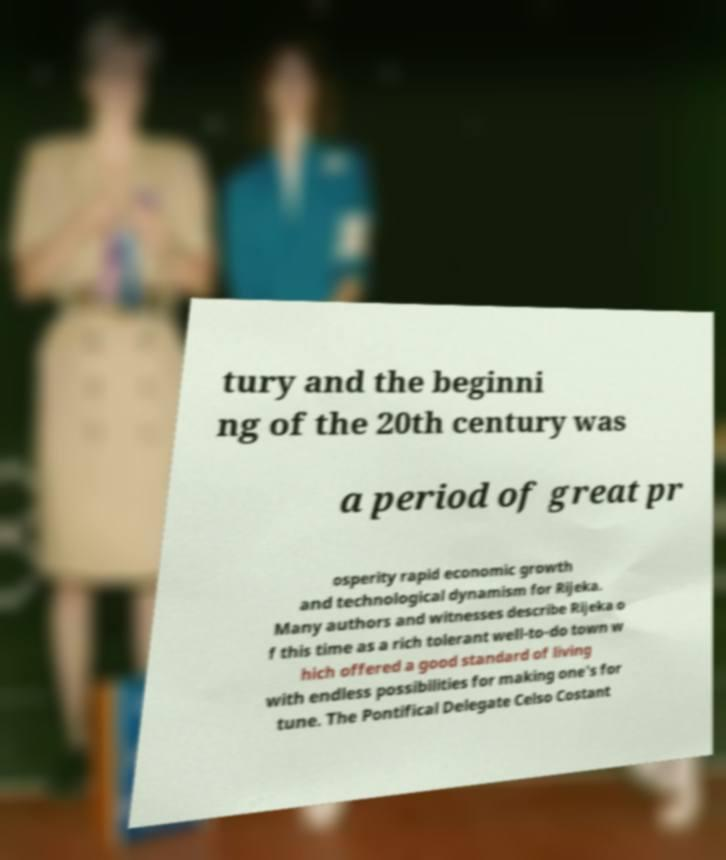I need the written content from this picture converted into text. Can you do that? tury and the beginni ng of the 20th century was a period of great pr osperity rapid economic growth and technological dynamism for Rijeka. Many authors and witnesses describe Rijeka o f this time as a rich tolerant well-to-do town w hich offered a good standard of living with endless possibilities for making one's for tune. The Pontifical Delegate Celso Costant 